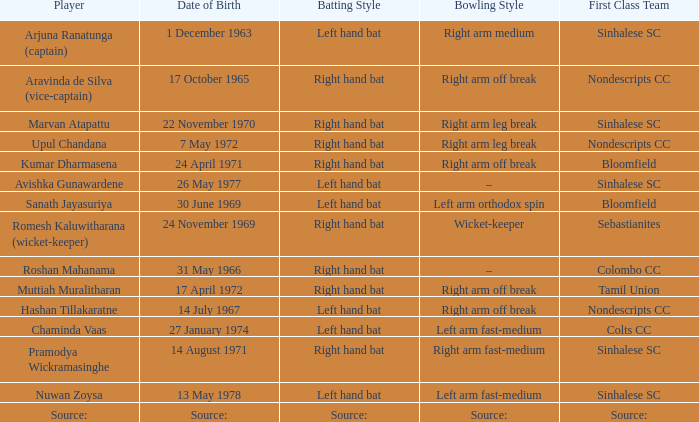When was avishka gunawardene born? 26 May 1977. 